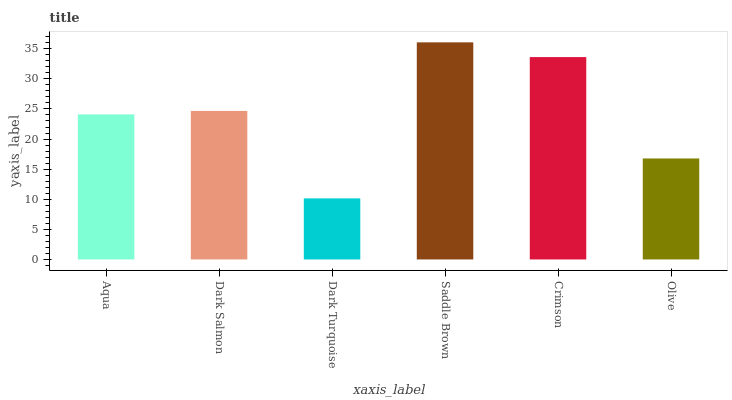Is Dark Salmon the minimum?
Answer yes or no. No. Is Dark Salmon the maximum?
Answer yes or no. No. Is Dark Salmon greater than Aqua?
Answer yes or no. Yes. Is Aqua less than Dark Salmon?
Answer yes or no. Yes. Is Aqua greater than Dark Salmon?
Answer yes or no. No. Is Dark Salmon less than Aqua?
Answer yes or no. No. Is Dark Salmon the high median?
Answer yes or no. Yes. Is Aqua the low median?
Answer yes or no. Yes. Is Crimson the high median?
Answer yes or no. No. Is Dark Turquoise the low median?
Answer yes or no. No. 